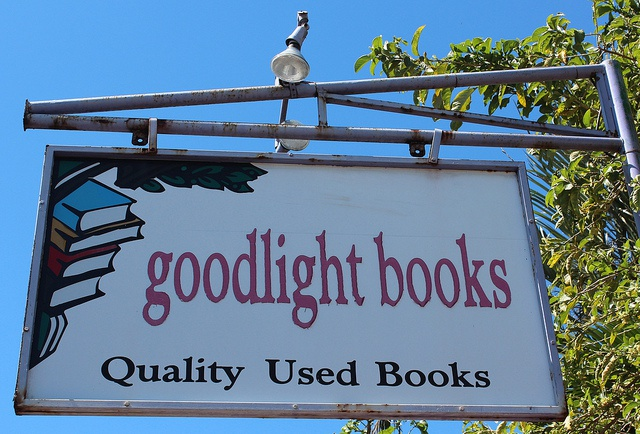Describe the objects in this image and their specific colors. I can see book in lightblue, blue, gray, and black tones, book in lightblue, black, gray, and maroon tones, book in lightblue, black, and gray tones, and book in lightblue, black, and gray tones in this image. 